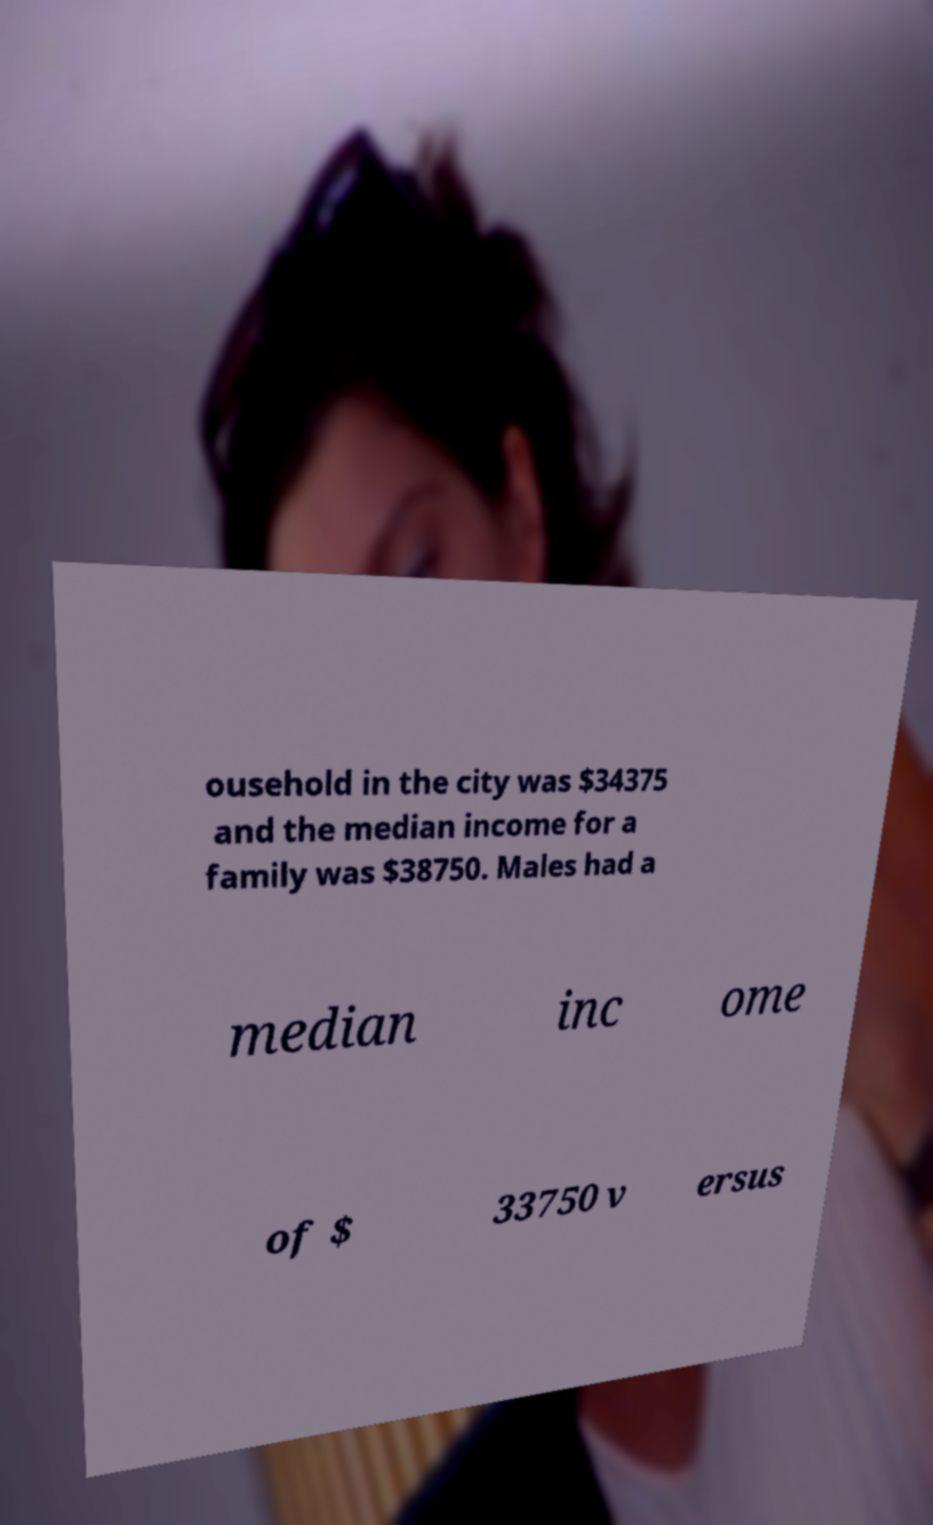Can you accurately transcribe the text from the provided image for me? ousehold in the city was $34375 and the median income for a family was $38750. Males had a median inc ome of $ 33750 v ersus 